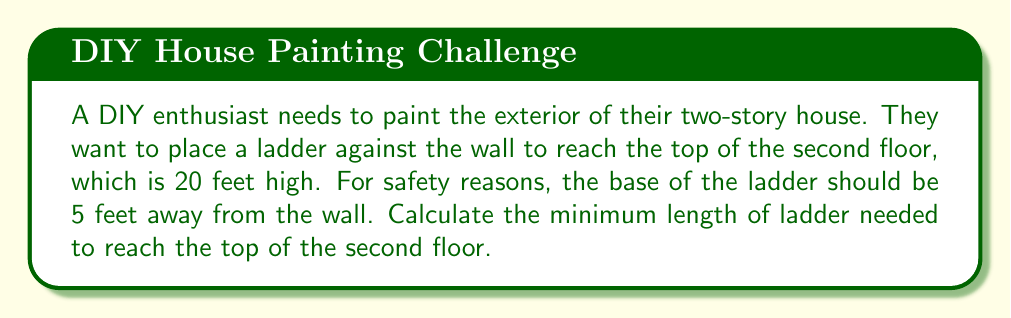Could you help me with this problem? Let's approach this step-by-step using trigonometry:

1) This scenario forms a right triangle, where:
   - The height of the wall (20 feet) is the opposite side
   - The distance from the wall to the ladder base (5 feet) is the adjacent side
   - The ladder forms the hypotenuse

2) We can visualize this as follows:

[asy]
unitsize(0.2cm);
draw((0,0)--(5,0)--(5,20)--(0,20)--cycle);
draw((0,0)--(5,20));
label("20 ft", (5.5,10), E);
label("5 ft", (2.5,-1), S);
label("Ladder", (1.5,11), NW);
[/asy]

3) To find the length of the ladder, we need to use the Pythagorean theorem:

   $a^2 + b^2 = c^2$

   Where $a$ is the adjacent side, $b$ is the opposite side, and $c$ is the hypotenuse (ladder length).

4) Substituting our known values:

   $5^2 + 20^2 = c^2$

5) Simplify:

   $25 + 400 = c^2$
   $425 = c^2$

6) Take the square root of both sides:

   $\sqrt{425} = c$

7) Simplify:

   $c \approx 20.616$ feet

8) Since we can't buy a fraction of a foot of ladder, we round up to the nearest foot:

   $c = 21$ feet
Answer: 21 feet 